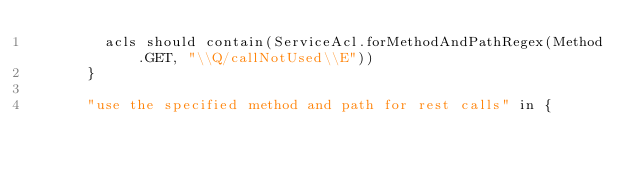<code> <loc_0><loc_0><loc_500><loc_500><_Scala_>        acls should contain(ServiceAcl.forMethodAndPathRegex(Method.GET, "\\Q/callNotUsed\\E"))
      }

      "use the specified method and path for rest calls" in {</code> 